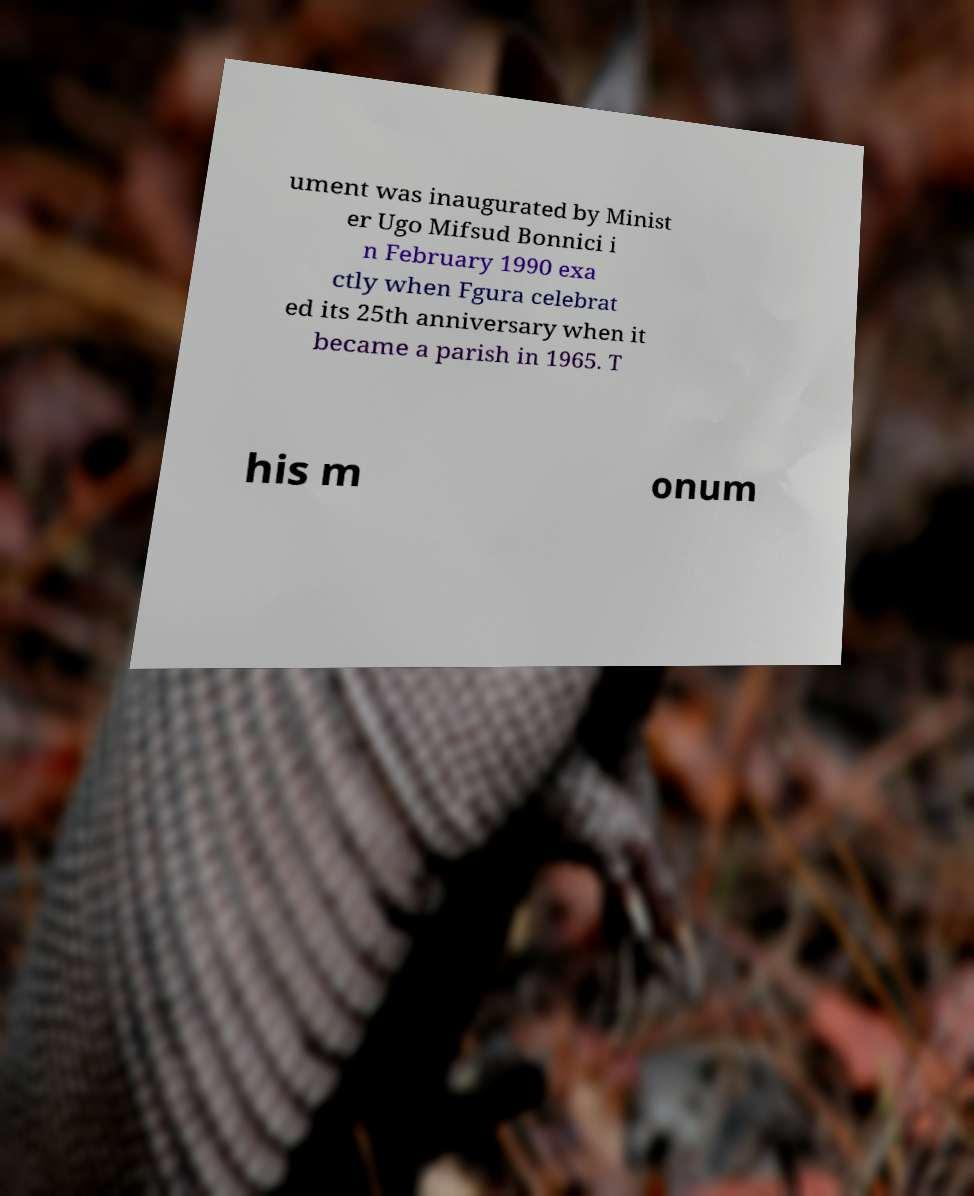Could you extract and type out the text from this image? ument was inaugurated by Minist er Ugo Mifsud Bonnici i n February 1990 exa ctly when Fgura celebrat ed its 25th anniversary when it became a parish in 1965. T his m onum 